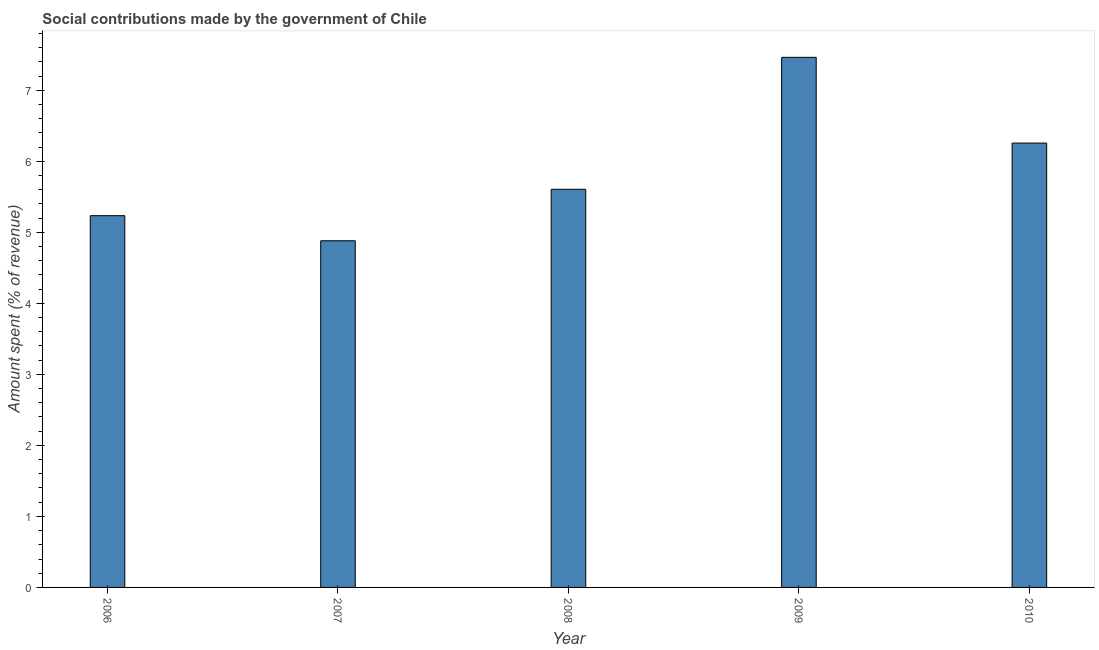What is the title of the graph?
Offer a very short reply. Social contributions made by the government of Chile. What is the label or title of the Y-axis?
Your answer should be very brief. Amount spent (% of revenue). What is the amount spent in making social contributions in 2007?
Your response must be concise. 4.88. Across all years, what is the maximum amount spent in making social contributions?
Keep it short and to the point. 7.46. Across all years, what is the minimum amount spent in making social contributions?
Your response must be concise. 4.88. In which year was the amount spent in making social contributions minimum?
Offer a terse response. 2007. What is the sum of the amount spent in making social contributions?
Provide a succinct answer. 29.44. What is the difference between the amount spent in making social contributions in 2007 and 2008?
Your answer should be very brief. -0.72. What is the average amount spent in making social contributions per year?
Offer a terse response. 5.89. What is the median amount spent in making social contributions?
Keep it short and to the point. 5.61. Do a majority of the years between 2009 and 2010 (inclusive) have amount spent in making social contributions greater than 6 %?
Provide a succinct answer. Yes. What is the ratio of the amount spent in making social contributions in 2007 to that in 2010?
Your answer should be compact. 0.78. Is the amount spent in making social contributions in 2006 less than that in 2009?
Provide a succinct answer. Yes. Is the difference between the amount spent in making social contributions in 2007 and 2010 greater than the difference between any two years?
Ensure brevity in your answer.  No. What is the difference between the highest and the second highest amount spent in making social contributions?
Make the answer very short. 1.21. What is the difference between the highest and the lowest amount spent in making social contributions?
Your answer should be compact. 2.58. Are all the bars in the graph horizontal?
Offer a very short reply. No. Are the values on the major ticks of Y-axis written in scientific E-notation?
Your answer should be very brief. No. What is the Amount spent (% of revenue) of 2006?
Offer a very short reply. 5.23. What is the Amount spent (% of revenue) of 2007?
Offer a very short reply. 4.88. What is the Amount spent (% of revenue) in 2008?
Your answer should be compact. 5.61. What is the Amount spent (% of revenue) in 2009?
Your answer should be very brief. 7.46. What is the Amount spent (% of revenue) of 2010?
Keep it short and to the point. 6.26. What is the difference between the Amount spent (% of revenue) in 2006 and 2007?
Keep it short and to the point. 0.35. What is the difference between the Amount spent (% of revenue) in 2006 and 2008?
Provide a short and direct response. -0.37. What is the difference between the Amount spent (% of revenue) in 2006 and 2009?
Keep it short and to the point. -2.23. What is the difference between the Amount spent (% of revenue) in 2006 and 2010?
Make the answer very short. -1.02. What is the difference between the Amount spent (% of revenue) in 2007 and 2008?
Offer a very short reply. -0.72. What is the difference between the Amount spent (% of revenue) in 2007 and 2009?
Provide a succinct answer. -2.58. What is the difference between the Amount spent (% of revenue) in 2007 and 2010?
Your response must be concise. -1.38. What is the difference between the Amount spent (% of revenue) in 2008 and 2009?
Offer a terse response. -1.86. What is the difference between the Amount spent (% of revenue) in 2008 and 2010?
Your answer should be compact. -0.65. What is the difference between the Amount spent (% of revenue) in 2009 and 2010?
Provide a succinct answer. 1.21. What is the ratio of the Amount spent (% of revenue) in 2006 to that in 2007?
Give a very brief answer. 1.07. What is the ratio of the Amount spent (% of revenue) in 2006 to that in 2008?
Give a very brief answer. 0.93. What is the ratio of the Amount spent (% of revenue) in 2006 to that in 2009?
Keep it short and to the point. 0.7. What is the ratio of the Amount spent (% of revenue) in 2006 to that in 2010?
Offer a terse response. 0.84. What is the ratio of the Amount spent (% of revenue) in 2007 to that in 2008?
Keep it short and to the point. 0.87. What is the ratio of the Amount spent (% of revenue) in 2007 to that in 2009?
Your answer should be compact. 0.65. What is the ratio of the Amount spent (% of revenue) in 2007 to that in 2010?
Ensure brevity in your answer.  0.78. What is the ratio of the Amount spent (% of revenue) in 2008 to that in 2009?
Your response must be concise. 0.75. What is the ratio of the Amount spent (% of revenue) in 2008 to that in 2010?
Provide a succinct answer. 0.9. What is the ratio of the Amount spent (% of revenue) in 2009 to that in 2010?
Offer a terse response. 1.19. 